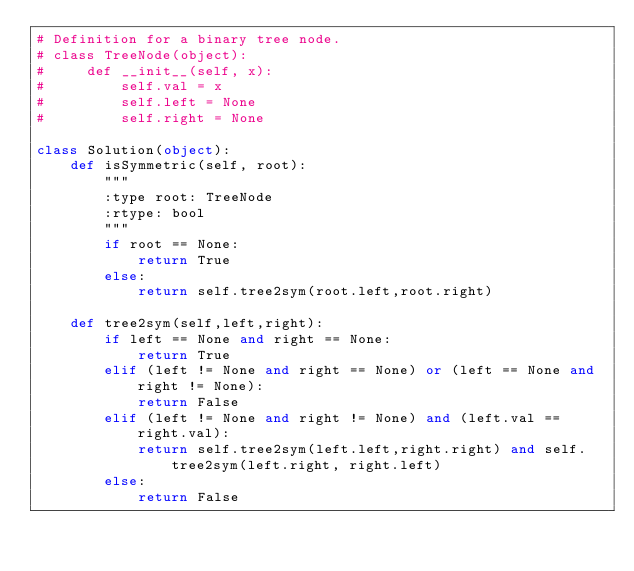Convert code to text. <code><loc_0><loc_0><loc_500><loc_500><_Python_># Definition for a binary tree node.
# class TreeNode(object):
#     def __init__(self, x):
#         self.val = x
#         self.left = None
#         self.right = None

class Solution(object):
    def isSymmetric(self, root):
        """
        :type root: TreeNode
        :rtype: bool
        """
        if root == None:
            return True
        else:
            return self.tree2sym(root.left,root.right)
    
    def tree2sym(self,left,right):
        if left == None and right == None:
            return True
        elif (left != None and right == None) or (left == None and right != None):
            return False
        elif (left != None and right != None) and (left.val == right.val):
            return self.tree2sym(left.left,right.right) and self.tree2sym(left.right, right.left)
        else:
            return False</code> 